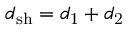Convert formula to latex. <formula><loc_0><loc_0><loc_500><loc_500>d _ { s h } = d _ { 1 } + d _ { 2 }</formula> 